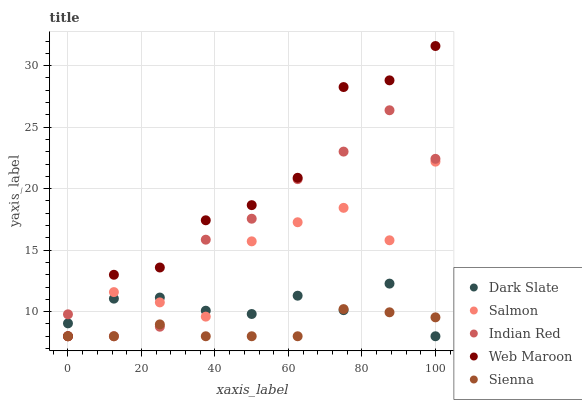Does Sienna have the minimum area under the curve?
Answer yes or no. Yes. Does Web Maroon have the maximum area under the curve?
Answer yes or no. Yes. Does Dark Slate have the minimum area under the curve?
Answer yes or no. No. Does Dark Slate have the maximum area under the curve?
Answer yes or no. No. Is Sienna the smoothest?
Answer yes or no. Yes. Is Salmon the roughest?
Answer yes or no. Yes. Is Dark Slate the smoothest?
Answer yes or no. No. Is Dark Slate the roughest?
Answer yes or no. No. Does Web Maroon have the lowest value?
Answer yes or no. Yes. Does Web Maroon have the highest value?
Answer yes or no. Yes. Does Dark Slate have the highest value?
Answer yes or no. No. Does Salmon intersect Dark Slate?
Answer yes or no. Yes. Is Salmon less than Dark Slate?
Answer yes or no. No. Is Salmon greater than Dark Slate?
Answer yes or no. No. 